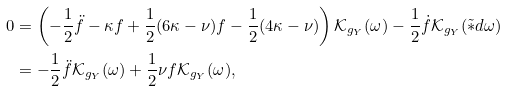<formula> <loc_0><loc_0><loc_500><loc_500>0 & = \left ( - \frac { 1 } { 2 } \ddot { f } - \kappa f + \frac { 1 } { 2 } ( 6 \kappa - \nu ) f - \frac { 1 } { 2 } ( 4 \kappa - \nu ) \right ) \mathcal { K } _ { g _ { Y } } ( \omega ) - \frac { 1 } { 2 } \dot { f } \mathcal { K } _ { g _ { Y } } ( \tilde { * } d \omega ) \\ & = - \frac { 1 } { 2 } \ddot { f } \mathcal { K } _ { g _ { Y } } ( \omega ) + \frac { 1 } { 2 } \nu f \mathcal { K } _ { g _ { Y } } ( \omega ) ,</formula> 